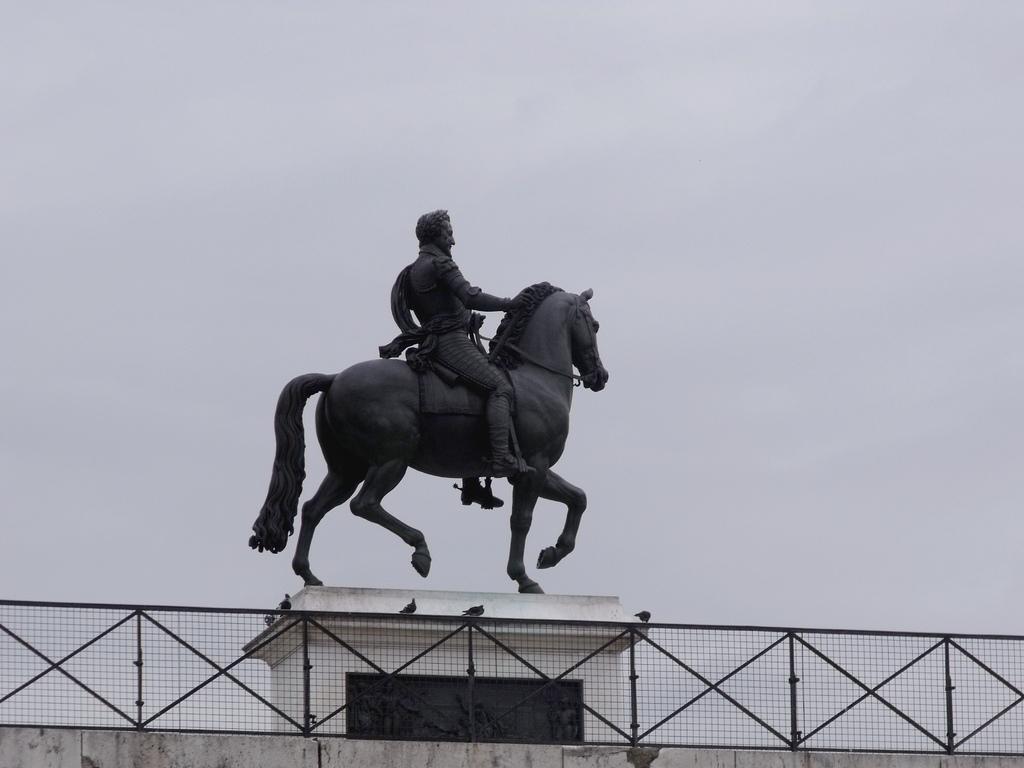Please provide a concise description of this image. In this picture I can see a sculpture of a person and horse, side we can see fencing. 